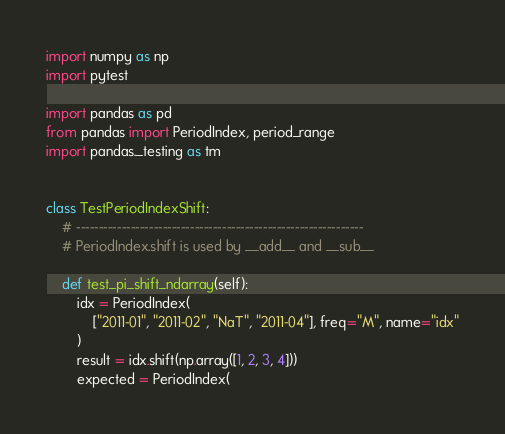<code> <loc_0><loc_0><loc_500><loc_500><_Python_>import numpy as np
import pytest

import pandas as pd
from pandas import PeriodIndex, period_range
import pandas._testing as tm


class TestPeriodIndexShift:
    # ---------------------------------------------------------------
    # PeriodIndex.shift is used by __add__ and __sub__

    def test_pi_shift_ndarray(self):
        idx = PeriodIndex(
            ["2011-01", "2011-02", "NaT", "2011-04"], freq="M", name="idx"
        )
        result = idx.shift(np.array([1, 2, 3, 4]))
        expected = PeriodIndex(</code> 